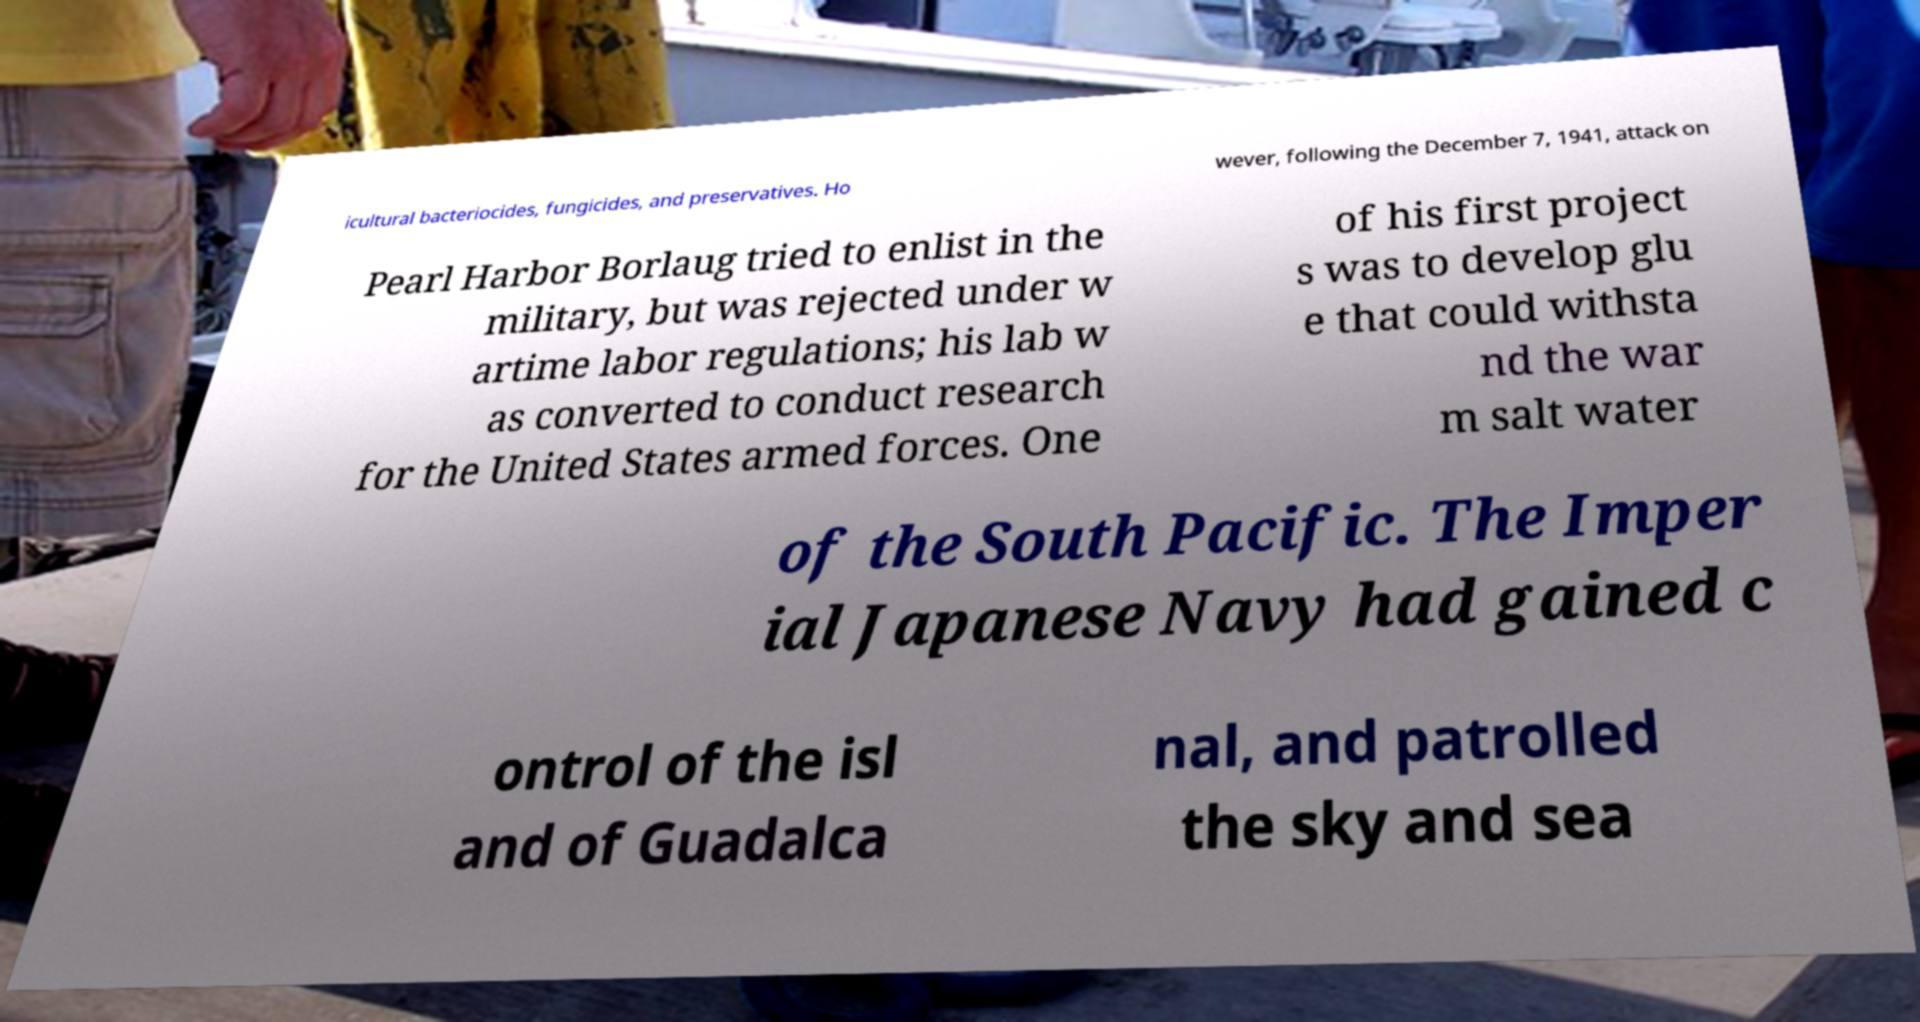Could you extract and type out the text from this image? icultural bacteriocides, fungicides, and preservatives. Ho wever, following the December 7, 1941, attack on Pearl Harbor Borlaug tried to enlist in the military, but was rejected under w artime labor regulations; his lab w as converted to conduct research for the United States armed forces. One of his first project s was to develop glu e that could withsta nd the war m salt water of the South Pacific. The Imper ial Japanese Navy had gained c ontrol of the isl and of Guadalca nal, and patrolled the sky and sea 